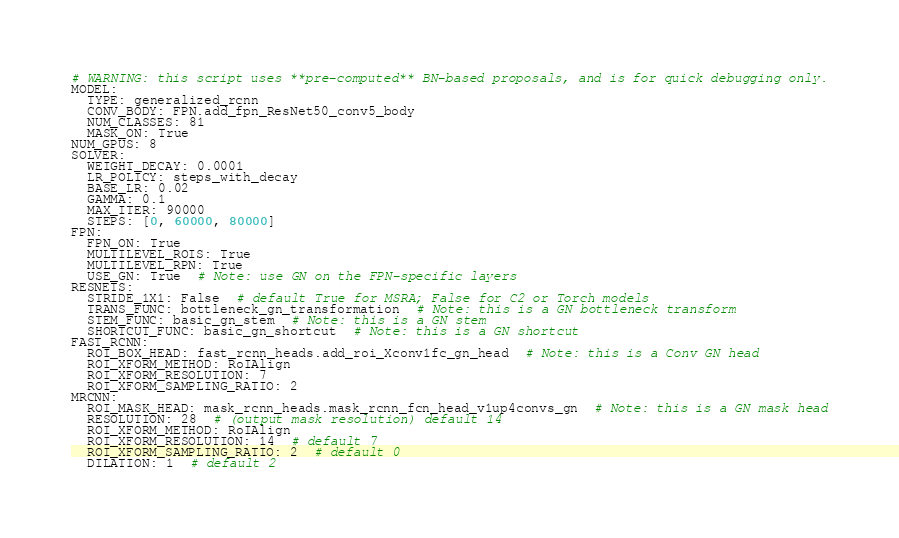<code> <loc_0><loc_0><loc_500><loc_500><_YAML_># WARNING: this script uses **pre-computed** BN-based proposals, and is for quick debugging only.
MODEL:
  TYPE: generalized_rcnn
  CONV_BODY: FPN.add_fpn_ResNet50_conv5_body
  NUM_CLASSES: 81
  MASK_ON: True
NUM_GPUS: 8
SOLVER:
  WEIGHT_DECAY: 0.0001
  LR_POLICY: steps_with_decay
  BASE_LR: 0.02
  GAMMA: 0.1
  MAX_ITER: 90000
  STEPS: [0, 60000, 80000]
FPN:
  FPN_ON: True
  MULTILEVEL_ROIS: True
  MULTILEVEL_RPN: True
  USE_GN: True  # Note: use GN on the FPN-specific layers
RESNETS:
  STRIDE_1X1: False  # default True for MSRA; False for C2 or Torch models
  TRANS_FUNC: bottleneck_gn_transformation  # Note: this is a GN bottleneck transform
  STEM_FUNC: basic_gn_stem  # Note: this is a GN stem
  SHORTCUT_FUNC: basic_gn_shortcut  # Note: this is a GN shortcut
FAST_RCNN:
  ROI_BOX_HEAD: fast_rcnn_heads.add_roi_Xconv1fc_gn_head  # Note: this is a Conv GN head
  ROI_XFORM_METHOD: RoIAlign
  ROI_XFORM_RESOLUTION: 7
  ROI_XFORM_SAMPLING_RATIO: 2
MRCNN:
  ROI_MASK_HEAD: mask_rcnn_heads.mask_rcnn_fcn_head_v1up4convs_gn  # Note: this is a GN mask head
  RESOLUTION: 28  # (output mask resolution) default 14
  ROI_XFORM_METHOD: RoIAlign
  ROI_XFORM_RESOLUTION: 14  # default 7
  ROI_XFORM_SAMPLING_RATIO: 2  # default 0
  DILATION: 1  # default 2</code> 